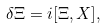Convert formula to latex. <formula><loc_0><loc_0><loc_500><loc_500>\delta \Xi = i [ \Xi , X ] ,</formula> 